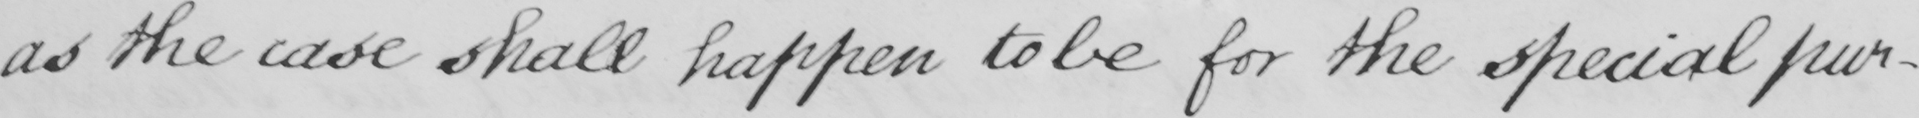What is written in this line of handwriting? as the case shall happen to be for the special pur- 